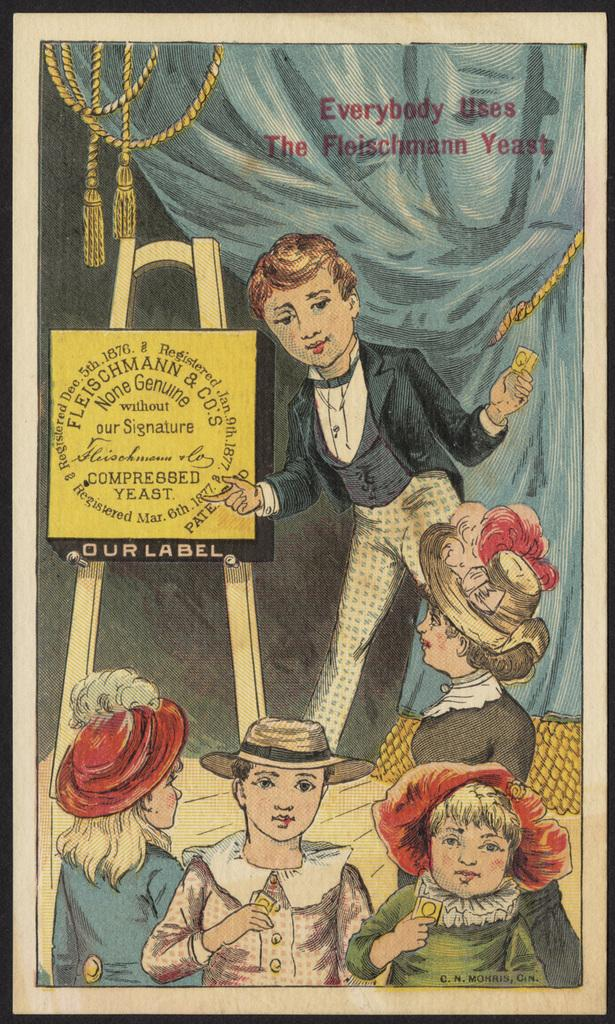What is the main subject of the image? There is a frame of people in the image. What else can be seen in the image besides the people? There is a board and ropes in the image. Is there any text present in the image? Yes, there is text in the image. Can you see a hill in the background of the image? There is no hill visible in the image. What type of face is depicted on the board in the image? There is no face depicted on the board in the image. 